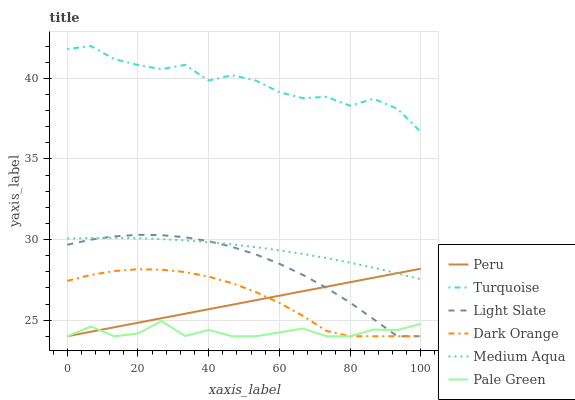Does Pale Green have the minimum area under the curve?
Answer yes or no. Yes. Does Turquoise have the maximum area under the curve?
Answer yes or no. Yes. Does Light Slate have the minimum area under the curve?
Answer yes or no. No. Does Light Slate have the maximum area under the curve?
Answer yes or no. No. Is Peru the smoothest?
Answer yes or no. Yes. Is Turquoise the roughest?
Answer yes or no. Yes. Is Light Slate the smoothest?
Answer yes or no. No. Is Light Slate the roughest?
Answer yes or no. No. Does Dark Orange have the lowest value?
Answer yes or no. Yes. Does Turquoise have the lowest value?
Answer yes or no. No. Does Turquoise have the highest value?
Answer yes or no. Yes. Does Light Slate have the highest value?
Answer yes or no. No. Is Light Slate less than Turquoise?
Answer yes or no. Yes. Is Turquoise greater than Light Slate?
Answer yes or no. Yes. Does Medium Aqua intersect Peru?
Answer yes or no. Yes. Is Medium Aqua less than Peru?
Answer yes or no. No. Is Medium Aqua greater than Peru?
Answer yes or no. No. Does Light Slate intersect Turquoise?
Answer yes or no. No. 